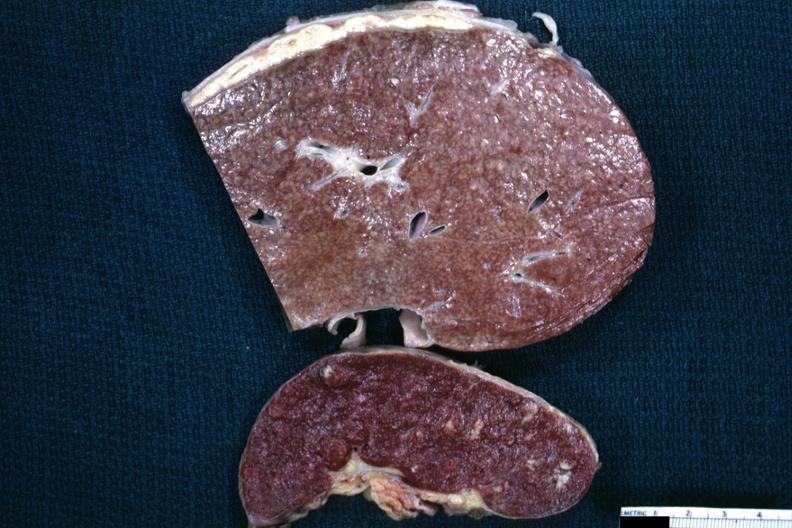what is granulomata slide typical cold abscess exudate on the liver surface?
Answer the question using a single word or phrase. A close-up view of 